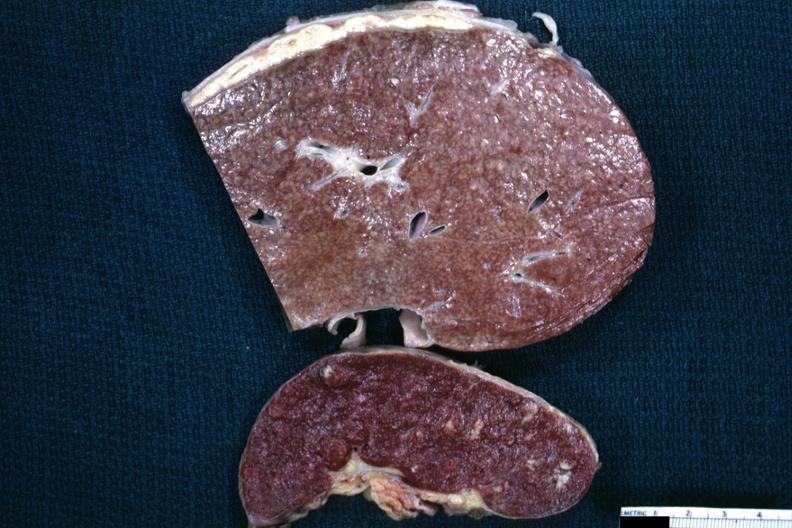what is granulomata slide typical cold abscess exudate on the liver surface?
Answer the question using a single word or phrase. A close-up view of 